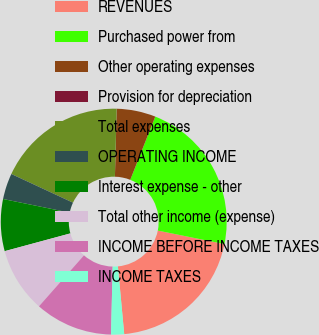Convert chart to OTSL. <chart><loc_0><loc_0><loc_500><loc_500><pie_chart><fcel>REVENUES<fcel>Purchased power from<fcel>Other operating expenses<fcel>Provision for depreciation<fcel>Total expenses<fcel>OPERATING INCOME<fcel>Interest expense - other<fcel>Total other income (expense)<fcel>INCOME BEFORE INCOME TAXES<fcel>INCOME TAXES<nl><fcel>20.34%<fcel>22.19%<fcel>5.57%<fcel>0.01%<fcel>18.48%<fcel>3.72%<fcel>7.42%<fcel>9.28%<fcel>11.13%<fcel>1.86%<nl></chart> 